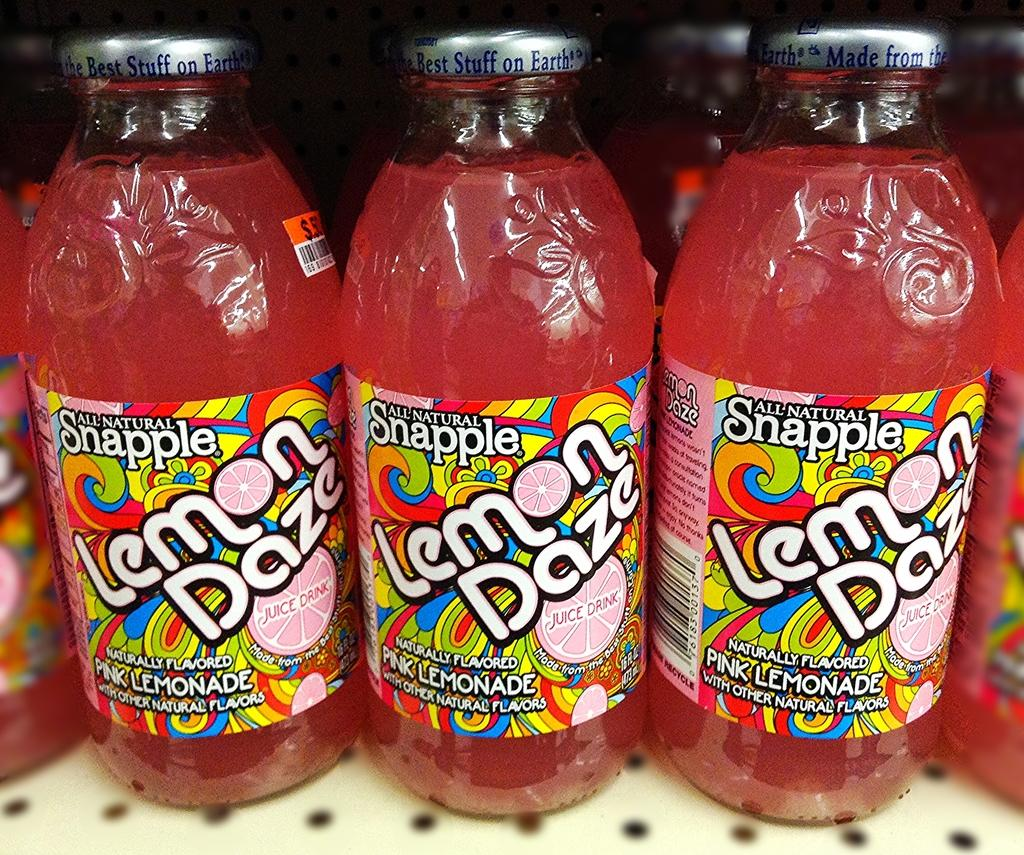How many bottles are visible in the image? There are three bottles in the image. What can be found on each bottle? Each bottle has a sticker on it. What is used to seal the bottles? Each bottle has a cap. What language is used on the stickers of the bottles in the image? The provided facts do not mention the language used on the stickers, so it cannot be determined from the image. 